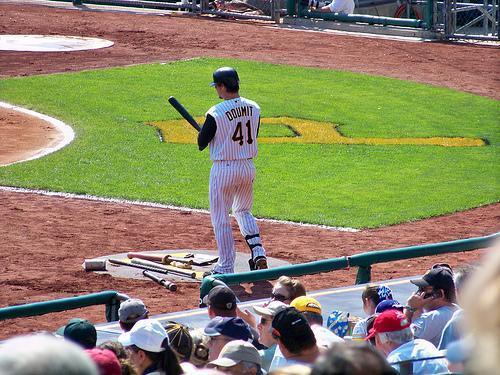How many people have a cellphone in their left hand?
Give a very brief answer. 1. How many people are playing football?
Give a very brief answer. 0. 